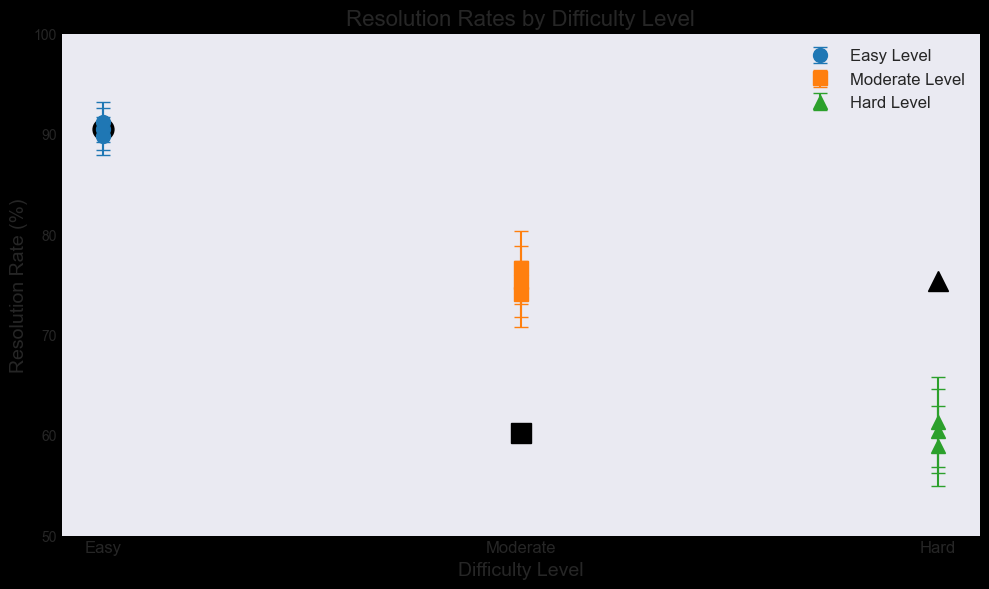What is the average resolution rate for Easy level tickets? The resolution rates for Easy level are 90.5%, 89.8%, and 91.2%. Adding these values gives 271.5%, and dividing by 3 (the number of values) gives an average of 90.5%.
Answer: 90.5% Which difficulty level has the highest average resolution rate? The average resolution rates are calculated as follows: Easy 90.5%, Moderate 75.3%, and Hard 60.2%. The highest is Easy level at 90.5%.
Answer: Easy What is the mean error margin for Hard level tickets? The error margins for Hard level are 4.2%, 4.0%, and 4.5%. Adding these values gives 12.7%, and dividing by 3 gives a mean error margin of approximately 4.23%.
Answer: 4.23% Which difficulty level has the highest variability in resolution rates considering the error margins? The error margins for each difficulty level are: Easy (2.1%, 1.9%, 2.0%), Moderate (3.5%, 3.3%, 3.6%), and Hard (4.2%, 4.0%, 4.5%). The highest average error margin, indicating more variability, is for Hard at approximately 4.23%.
Answer: Hard Which difficulty level has the lowest minimum resolution rate? The minimum resolution rates for each difficulty level are: Easy (89.8%), Moderate (74.1%), Hard (58.9%). The lowest is Hard at 58.9%.
Answer: Hard What's the overall range of resolution rates visible in the figure? The range is calculated by subtracting the lowest resolution rate (58.9% for Hard) from the highest resolution rate (91.2% for Easy), giving a range of 32.3%.
Answer: 32.3% How does the average resolution rate for Moderate level compare to Hard level? The average resolution rates are: Moderate 75.3% and Hard 60.2%. To compare, subtract Hard from Moderate: 75.3% - 60.2% = 15.1%. Moderate is 15.1% higher than Hard.
Answer: 15.1% Which level has the largest error bar components observed? The error margins for Hard level are visually the largest at approximately 4.0% to 4.5%.
Answer: Hard Considering the error margins, do any levels' resolution rates overlap visually? Given the error bars:
- Easy (88.4% to 93.3%)
- Moderate (71.8% to 78.8%)
- Hard (56.2% to 64.9%)
There is no overlap, indicating distinct resolution distributions.
Answer: No 